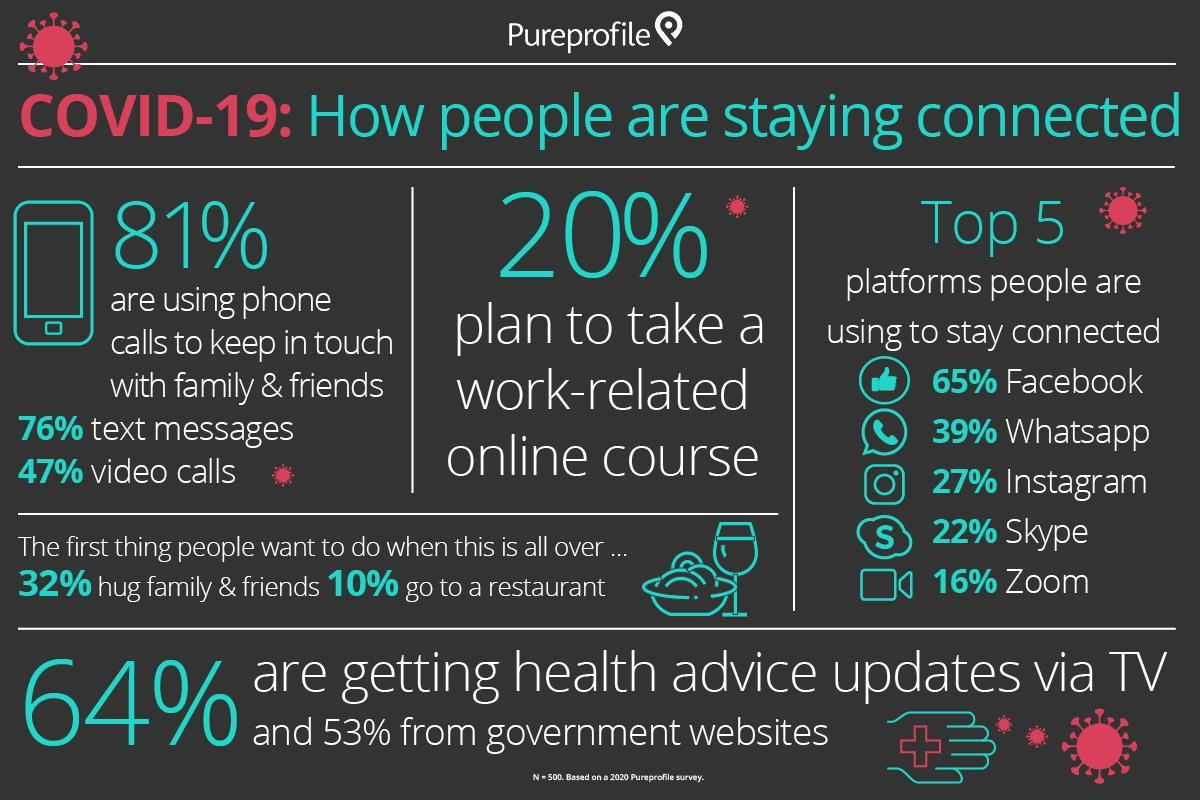Which is the top used social platform by world population to stay connected with family & friends during Covid 19?
Answer the question with a short phrase. Facebook What percentage of World population are getting Covid 19 related health advice updates via government websites? 53% Which is the second most used social platform by world population to stay connected with family & friends during Covid 19? Whatsapp What percentage of World population are getting Covid 19 related health advice updates via TV? 64% Which is the third most used social platform by world population to stay connected with family & friends during Covid 19? Instagram What percentage of world population rely on video calls via phone to keep in touch with family & friends during Covid 19? 47% Which is the least used social platform by world population to stay connected with family & friends during Covid 19? Zoom What percentage of world population rely on phone to keep in touch with family & friends during Covid 19? 81% What percentage of world population took work-related online course during Covid 19? 20% What percentage of World population wishes to go to a restaurant after Covid 19? 10% 